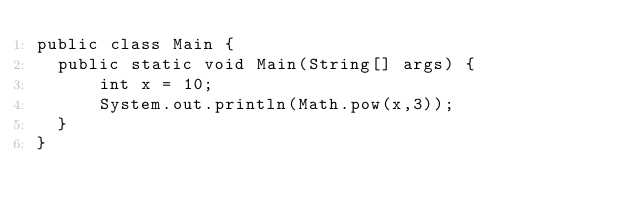Convert code to text. <code><loc_0><loc_0><loc_500><loc_500><_Java_>public class Main {
  public static void Main(String[] args) {
      int x = 10;
      System.out.println(Math.pow(x,3));
  }
}</code> 